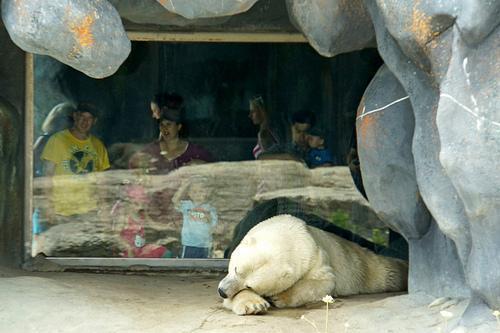How many bears are there?
Give a very brief answer. 1. 